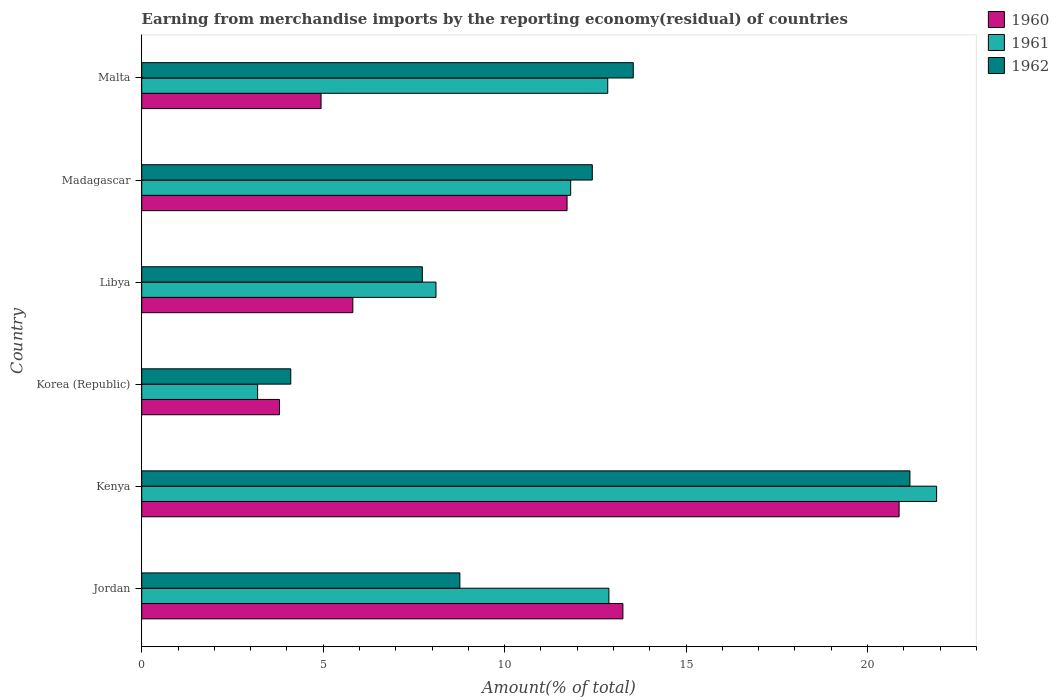How many different coloured bars are there?
Make the answer very short. 3. How many groups of bars are there?
Your response must be concise. 6. How many bars are there on the 3rd tick from the top?
Offer a terse response. 3. How many bars are there on the 3rd tick from the bottom?
Make the answer very short. 3. What is the percentage of amount earned from merchandise imports in 1962 in Jordan?
Provide a short and direct response. 8.77. Across all countries, what is the maximum percentage of amount earned from merchandise imports in 1961?
Provide a succinct answer. 21.91. Across all countries, what is the minimum percentage of amount earned from merchandise imports in 1960?
Your answer should be very brief. 3.8. In which country was the percentage of amount earned from merchandise imports in 1960 maximum?
Make the answer very short. Kenya. What is the total percentage of amount earned from merchandise imports in 1961 in the graph?
Offer a very short reply. 70.75. What is the difference between the percentage of amount earned from merchandise imports in 1960 in Libya and that in Malta?
Provide a short and direct response. 0.88. What is the difference between the percentage of amount earned from merchandise imports in 1961 in Madagascar and the percentage of amount earned from merchandise imports in 1960 in Korea (Republic)?
Your answer should be very brief. 8.03. What is the average percentage of amount earned from merchandise imports in 1962 per country?
Ensure brevity in your answer.  11.29. What is the difference between the percentage of amount earned from merchandise imports in 1962 and percentage of amount earned from merchandise imports in 1961 in Korea (Republic)?
Make the answer very short. 0.91. In how many countries, is the percentage of amount earned from merchandise imports in 1960 greater than 12 %?
Make the answer very short. 2. What is the ratio of the percentage of amount earned from merchandise imports in 1962 in Kenya to that in Korea (Republic)?
Keep it short and to the point. 5.15. Is the percentage of amount earned from merchandise imports in 1961 in Jordan less than that in Libya?
Provide a succinct answer. No. Is the difference between the percentage of amount earned from merchandise imports in 1962 in Jordan and Kenya greater than the difference between the percentage of amount earned from merchandise imports in 1961 in Jordan and Kenya?
Offer a terse response. No. What is the difference between the highest and the second highest percentage of amount earned from merchandise imports in 1962?
Your response must be concise. 7.62. What is the difference between the highest and the lowest percentage of amount earned from merchandise imports in 1960?
Your response must be concise. 17.08. How many bars are there?
Offer a very short reply. 18. What is the difference between two consecutive major ticks on the X-axis?
Give a very brief answer. 5. Does the graph contain grids?
Offer a terse response. No. Where does the legend appear in the graph?
Your response must be concise. Top right. How many legend labels are there?
Your response must be concise. 3. What is the title of the graph?
Your answer should be compact. Earning from merchandise imports by the reporting economy(residual) of countries. What is the label or title of the X-axis?
Offer a very short reply. Amount(% of total). What is the Amount(% of total) in 1960 in Jordan?
Keep it short and to the point. 13.26. What is the Amount(% of total) of 1961 in Jordan?
Keep it short and to the point. 12.88. What is the Amount(% of total) of 1962 in Jordan?
Provide a succinct answer. 8.77. What is the Amount(% of total) of 1960 in Kenya?
Make the answer very short. 20.87. What is the Amount(% of total) of 1961 in Kenya?
Provide a succinct answer. 21.91. What is the Amount(% of total) of 1962 in Kenya?
Keep it short and to the point. 21.17. What is the Amount(% of total) in 1960 in Korea (Republic)?
Provide a succinct answer. 3.8. What is the Amount(% of total) of 1961 in Korea (Republic)?
Give a very brief answer. 3.19. What is the Amount(% of total) in 1962 in Korea (Republic)?
Offer a very short reply. 4.11. What is the Amount(% of total) in 1960 in Libya?
Provide a short and direct response. 5.82. What is the Amount(% of total) in 1961 in Libya?
Keep it short and to the point. 8.11. What is the Amount(% of total) in 1962 in Libya?
Offer a very short reply. 7.73. What is the Amount(% of total) in 1960 in Madagascar?
Your answer should be compact. 11.72. What is the Amount(% of total) in 1961 in Madagascar?
Make the answer very short. 11.82. What is the Amount(% of total) in 1962 in Madagascar?
Give a very brief answer. 12.42. What is the Amount(% of total) of 1960 in Malta?
Make the answer very short. 4.94. What is the Amount(% of total) in 1961 in Malta?
Ensure brevity in your answer.  12.84. What is the Amount(% of total) in 1962 in Malta?
Make the answer very short. 13.55. Across all countries, what is the maximum Amount(% of total) of 1960?
Your answer should be very brief. 20.87. Across all countries, what is the maximum Amount(% of total) in 1961?
Provide a succinct answer. 21.91. Across all countries, what is the maximum Amount(% of total) of 1962?
Offer a terse response. 21.17. Across all countries, what is the minimum Amount(% of total) of 1960?
Offer a very short reply. 3.8. Across all countries, what is the minimum Amount(% of total) in 1961?
Give a very brief answer. 3.19. Across all countries, what is the minimum Amount(% of total) in 1962?
Ensure brevity in your answer.  4.11. What is the total Amount(% of total) of 1960 in the graph?
Offer a terse response. 60.41. What is the total Amount(% of total) of 1961 in the graph?
Your response must be concise. 70.75. What is the total Amount(% of total) in 1962 in the graph?
Your answer should be very brief. 67.74. What is the difference between the Amount(% of total) in 1960 in Jordan and that in Kenya?
Provide a short and direct response. -7.61. What is the difference between the Amount(% of total) in 1961 in Jordan and that in Kenya?
Give a very brief answer. -9.03. What is the difference between the Amount(% of total) in 1962 in Jordan and that in Kenya?
Make the answer very short. -12.4. What is the difference between the Amount(% of total) of 1960 in Jordan and that in Korea (Republic)?
Keep it short and to the point. 9.46. What is the difference between the Amount(% of total) of 1961 in Jordan and that in Korea (Republic)?
Keep it short and to the point. 9.68. What is the difference between the Amount(% of total) in 1962 in Jordan and that in Korea (Republic)?
Keep it short and to the point. 4.66. What is the difference between the Amount(% of total) of 1960 in Jordan and that in Libya?
Offer a terse response. 7.44. What is the difference between the Amount(% of total) in 1961 in Jordan and that in Libya?
Ensure brevity in your answer.  4.77. What is the difference between the Amount(% of total) of 1962 in Jordan and that in Libya?
Offer a terse response. 1.03. What is the difference between the Amount(% of total) of 1960 in Jordan and that in Madagascar?
Your answer should be compact. 1.54. What is the difference between the Amount(% of total) of 1961 in Jordan and that in Madagascar?
Provide a short and direct response. 1.05. What is the difference between the Amount(% of total) of 1962 in Jordan and that in Madagascar?
Your response must be concise. -3.65. What is the difference between the Amount(% of total) of 1960 in Jordan and that in Malta?
Provide a short and direct response. 8.32. What is the difference between the Amount(% of total) of 1961 in Jordan and that in Malta?
Offer a very short reply. 0.03. What is the difference between the Amount(% of total) of 1962 in Jordan and that in Malta?
Keep it short and to the point. -4.78. What is the difference between the Amount(% of total) of 1960 in Kenya and that in Korea (Republic)?
Offer a very short reply. 17.08. What is the difference between the Amount(% of total) of 1961 in Kenya and that in Korea (Republic)?
Keep it short and to the point. 18.71. What is the difference between the Amount(% of total) of 1962 in Kenya and that in Korea (Republic)?
Make the answer very short. 17.06. What is the difference between the Amount(% of total) of 1960 in Kenya and that in Libya?
Make the answer very short. 15.06. What is the difference between the Amount(% of total) of 1961 in Kenya and that in Libya?
Your response must be concise. 13.8. What is the difference between the Amount(% of total) of 1962 in Kenya and that in Libya?
Ensure brevity in your answer.  13.44. What is the difference between the Amount(% of total) in 1960 in Kenya and that in Madagascar?
Ensure brevity in your answer.  9.15. What is the difference between the Amount(% of total) in 1961 in Kenya and that in Madagascar?
Ensure brevity in your answer.  10.09. What is the difference between the Amount(% of total) in 1962 in Kenya and that in Madagascar?
Give a very brief answer. 8.75. What is the difference between the Amount(% of total) in 1960 in Kenya and that in Malta?
Provide a short and direct response. 15.93. What is the difference between the Amount(% of total) of 1961 in Kenya and that in Malta?
Keep it short and to the point. 9.06. What is the difference between the Amount(% of total) of 1962 in Kenya and that in Malta?
Provide a succinct answer. 7.62. What is the difference between the Amount(% of total) in 1960 in Korea (Republic) and that in Libya?
Provide a short and direct response. -2.02. What is the difference between the Amount(% of total) in 1961 in Korea (Republic) and that in Libya?
Your response must be concise. -4.92. What is the difference between the Amount(% of total) in 1962 in Korea (Republic) and that in Libya?
Provide a succinct answer. -3.63. What is the difference between the Amount(% of total) in 1960 in Korea (Republic) and that in Madagascar?
Give a very brief answer. -7.93. What is the difference between the Amount(% of total) of 1961 in Korea (Republic) and that in Madagascar?
Your answer should be compact. -8.63. What is the difference between the Amount(% of total) of 1962 in Korea (Republic) and that in Madagascar?
Give a very brief answer. -8.31. What is the difference between the Amount(% of total) in 1960 in Korea (Republic) and that in Malta?
Offer a very short reply. -1.15. What is the difference between the Amount(% of total) in 1961 in Korea (Republic) and that in Malta?
Keep it short and to the point. -9.65. What is the difference between the Amount(% of total) of 1962 in Korea (Republic) and that in Malta?
Your answer should be very brief. -9.44. What is the difference between the Amount(% of total) of 1960 in Libya and that in Madagascar?
Your answer should be very brief. -5.9. What is the difference between the Amount(% of total) of 1961 in Libya and that in Madagascar?
Ensure brevity in your answer.  -3.71. What is the difference between the Amount(% of total) in 1962 in Libya and that in Madagascar?
Offer a terse response. -4.68. What is the difference between the Amount(% of total) of 1960 in Libya and that in Malta?
Your response must be concise. 0.88. What is the difference between the Amount(% of total) of 1961 in Libya and that in Malta?
Provide a succinct answer. -4.73. What is the difference between the Amount(% of total) of 1962 in Libya and that in Malta?
Offer a very short reply. -5.81. What is the difference between the Amount(% of total) in 1960 in Madagascar and that in Malta?
Give a very brief answer. 6.78. What is the difference between the Amount(% of total) of 1961 in Madagascar and that in Malta?
Provide a succinct answer. -1.02. What is the difference between the Amount(% of total) in 1962 in Madagascar and that in Malta?
Give a very brief answer. -1.13. What is the difference between the Amount(% of total) in 1960 in Jordan and the Amount(% of total) in 1961 in Kenya?
Provide a succinct answer. -8.65. What is the difference between the Amount(% of total) of 1960 in Jordan and the Amount(% of total) of 1962 in Kenya?
Your response must be concise. -7.91. What is the difference between the Amount(% of total) of 1961 in Jordan and the Amount(% of total) of 1962 in Kenya?
Offer a very short reply. -8.3. What is the difference between the Amount(% of total) of 1960 in Jordan and the Amount(% of total) of 1961 in Korea (Republic)?
Your answer should be very brief. 10.07. What is the difference between the Amount(% of total) of 1960 in Jordan and the Amount(% of total) of 1962 in Korea (Republic)?
Provide a succinct answer. 9.15. What is the difference between the Amount(% of total) in 1961 in Jordan and the Amount(% of total) in 1962 in Korea (Republic)?
Ensure brevity in your answer.  8.77. What is the difference between the Amount(% of total) in 1960 in Jordan and the Amount(% of total) in 1961 in Libya?
Your answer should be compact. 5.15. What is the difference between the Amount(% of total) of 1960 in Jordan and the Amount(% of total) of 1962 in Libya?
Your answer should be very brief. 5.53. What is the difference between the Amount(% of total) of 1961 in Jordan and the Amount(% of total) of 1962 in Libya?
Ensure brevity in your answer.  5.14. What is the difference between the Amount(% of total) in 1960 in Jordan and the Amount(% of total) in 1961 in Madagascar?
Make the answer very short. 1.44. What is the difference between the Amount(% of total) of 1960 in Jordan and the Amount(% of total) of 1962 in Madagascar?
Make the answer very short. 0.84. What is the difference between the Amount(% of total) of 1961 in Jordan and the Amount(% of total) of 1962 in Madagascar?
Provide a short and direct response. 0.46. What is the difference between the Amount(% of total) in 1960 in Jordan and the Amount(% of total) in 1961 in Malta?
Your response must be concise. 0.42. What is the difference between the Amount(% of total) of 1960 in Jordan and the Amount(% of total) of 1962 in Malta?
Provide a succinct answer. -0.29. What is the difference between the Amount(% of total) of 1961 in Jordan and the Amount(% of total) of 1962 in Malta?
Give a very brief answer. -0.67. What is the difference between the Amount(% of total) in 1960 in Kenya and the Amount(% of total) in 1961 in Korea (Republic)?
Your answer should be compact. 17.68. What is the difference between the Amount(% of total) of 1960 in Kenya and the Amount(% of total) of 1962 in Korea (Republic)?
Provide a short and direct response. 16.77. What is the difference between the Amount(% of total) of 1961 in Kenya and the Amount(% of total) of 1962 in Korea (Republic)?
Your answer should be very brief. 17.8. What is the difference between the Amount(% of total) of 1960 in Kenya and the Amount(% of total) of 1961 in Libya?
Give a very brief answer. 12.76. What is the difference between the Amount(% of total) in 1960 in Kenya and the Amount(% of total) in 1962 in Libya?
Offer a very short reply. 13.14. What is the difference between the Amount(% of total) of 1961 in Kenya and the Amount(% of total) of 1962 in Libya?
Provide a succinct answer. 14.17. What is the difference between the Amount(% of total) of 1960 in Kenya and the Amount(% of total) of 1961 in Madagascar?
Ensure brevity in your answer.  9.05. What is the difference between the Amount(% of total) in 1960 in Kenya and the Amount(% of total) in 1962 in Madagascar?
Offer a very short reply. 8.46. What is the difference between the Amount(% of total) of 1961 in Kenya and the Amount(% of total) of 1962 in Madagascar?
Your response must be concise. 9.49. What is the difference between the Amount(% of total) of 1960 in Kenya and the Amount(% of total) of 1961 in Malta?
Provide a short and direct response. 8.03. What is the difference between the Amount(% of total) in 1960 in Kenya and the Amount(% of total) in 1962 in Malta?
Your answer should be very brief. 7.33. What is the difference between the Amount(% of total) of 1961 in Kenya and the Amount(% of total) of 1962 in Malta?
Ensure brevity in your answer.  8.36. What is the difference between the Amount(% of total) of 1960 in Korea (Republic) and the Amount(% of total) of 1961 in Libya?
Your response must be concise. -4.31. What is the difference between the Amount(% of total) of 1960 in Korea (Republic) and the Amount(% of total) of 1962 in Libya?
Offer a very short reply. -3.94. What is the difference between the Amount(% of total) of 1961 in Korea (Republic) and the Amount(% of total) of 1962 in Libya?
Offer a very short reply. -4.54. What is the difference between the Amount(% of total) of 1960 in Korea (Republic) and the Amount(% of total) of 1961 in Madagascar?
Offer a terse response. -8.03. What is the difference between the Amount(% of total) of 1960 in Korea (Republic) and the Amount(% of total) of 1962 in Madagascar?
Ensure brevity in your answer.  -8.62. What is the difference between the Amount(% of total) of 1961 in Korea (Republic) and the Amount(% of total) of 1962 in Madagascar?
Provide a succinct answer. -9.22. What is the difference between the Amount(% of total) of 1960 in Korea (Republic) and the Amount(% of total) of 1961 in Malta?
Offer a very short reply. -9.05. What is the difference between the Amount(% of total) in 1960 in Korea (Republic) and the Amount(% of total) in 1962 in Malta?
Your answer should be compact. -9.75. What is the difference between the Amount(% of total) of 1961 in Korea (Republic) and the Amount(% of total) of 1962 in Malta?
Ensure brevity in your answer.  -10.35. What is the difference between the Amount(% of total) of 1960 in Libya and the Amount(% of total) of 1961 in Madagascar?
Offer a terse response. -6. What is the difference between the Amount(% of total) of 1960 in Libya and the Amount(% of total) of 1962 in Madagascar?
Your answer should be very brief. -6.6. What is the difference between the Amount(% of total) of 1961 in Libya and the Amount(% of total) of 1962 in Madagascar?
Make the answer very short. -4.31. What is the difference between the Amount(% of total) in 1960 in Libya and the Amount(% of total) in 1961 in Malta?
Provide a short and direct response. -7.03. What is the difference between the Amount(% of total) of 1960 in Libya and the Amount(% of total) of 1962 in Malta?
Your answer should be very brief. -7.73. What is the difference between the Amount(% of total) of 1961 in Libya and the Amount(% of total) of 1962 in Malta?
Ensure brevity in your answer.  -5.44. What is the difference between the Amount(% of total) in 1960 in Madagascar and the Amount(% of total) in 1961 in Malta?
Offer a very short reply. -1.12. What is the difference between the Amount(% of total) in 1960 in Madagascar and the Amount(% of total) in 1962 in Malta?
Your answer should be very brief. -1.82. What is the difference between the Amount(% of total) in 1961 in Madagascar and the Amount(% of total) in 1962 in Malta?
Provide a succinct answer. -1.73. What is the average Amount(% of total) of 1960 per country?
Ensure brevity in your answer.  10.07. What is the average Amount(% of total) in 1961 per country?
Keep it short and to the point. 11.79. What is the average Amount(% of total) in 1962 per country?
Provide a short and direct response. 11.29. What is the difference between the Amount(% of total) in 1960 and Amount(% of total) in 1961 in Jordan?
Keep it short and to the point. 0.39. What is the difference between the Amount(% of total) in 1960 and Amount(% of total) in 1962 in Jordan?
Make the answer very short. 4.49. What is the difference between the Amount(% of total) in 1961 and Amount(% of total) in 1962 in Jordan?
Ensure brevity in your answer.  4.11. What is the difference between the Amount(% of total) of 1960 and Amount(% of total) of 1961 in Kenya?
Your response must be concise. -1.03. What is the difference between the Amount(% of total) of 1960 and Amount(% of total) of 1962 in Kenya?
Provide a short and direct response. -0.3. What is the difference between the Amount(% of total) in 1961 and Amount(% of total) in 1962 in Kenya?
Keep it short and to the point. 0.74. What is the difference between the Amount(% of total) of 1960 and Amount(% of total) of 1961 in Korea (Republic)?
Offer a very short reply. 0.6. What is the difference between the Amount(% of total) in 1960 and Amount(% of total) in 1962 in Korea (Republic)?
Your answer should be very brief. -0.31. What is the difference between the Amount(% of total) in 1961 and Amount(% of total) in 1962 in Korea (Republic)?
Offer a very short reply. -0.91. What is the difference between the Amount(% of total) in 1960 and Amount(% of total) in 1961 in Libya?
Your answer should be compact. -2.29. What is the difference between the Amount(% of total) of 1960 and Amount(% of total) of 1962 in Libya?
Provide a succinct answer. -1.92. What is the difference between the Amount(% of total) of 1961 and Amount(% of total) of 1962 in Libya?
Give a very brief answer. 0.38. What is the difference between the Amount(% of total) of 1960 and Amount(% of total) of 1961 in Madagascar?
Offer a very short reply. -0.1. What is the difference between the Amount(% of total) in 1960 and Amount(% of total) in 1962 in Madagascar?
Ensure brevity in your answer.  -0.7. What is the difference between the Amount(% of total) in 1961 and Amount(% of total) in 1962 in Madagascar?
Provide a succinct answer. -0.6. What is the difference between the Amount(% of total) in 1960 and Amount(% of total) in 1961 in Malta?
Give a very brief answer. -7.9. What is the difference between the Amount(% of total) in 1960 and Amount(% of total) in 1962 in Malta?
Offer a terse response. -8.6. What is the difference between the Amount(% of total) in 1961 and Amount(% of total) in 1962 in Malta?
Give a very brief answer. -0.7. What is the ratio of the Amount(% of total) of 1960 in Jordan to that in Kenya?
Offer a very short reply. 0.64. What is the ratio of the Amount(% of total) in 1961 in Jordan to that in Kenya?
Keep it short and to the point. 0.59. What is the ratio of the Amount(% of total) in 1962 in Jordan to that in Kenya?
Your answer should be compact. 0.41. What is the ratio of the Amount(% of total) in 1960 in Jordan to that in Korea (Republic)?
Provide a succinct answer. 3.49. What is the ratio of the Amount(% of total) of 1961 in Jordan to that in Korea (Republic)?
Offer a very short reply. 4.03. What is the ratio of the Amount(% of total) of 1962 in Jordan to that in Korea (Republic)?
Provide a short and direct response. 2.13. What is the ratio of the Amount(% of total) in 1960 in Jordan to that in Libya?
Provide a succinct answer. 2.28. What is the ratio of the Amount(% of total) of 1961 in Jordan to that in Libya?
Your response must be concise. 1.59. What is the ratio of the Amount(% of total) of 1962 in Jordan to that in Libya?
Ensure brevity in your answer.  1.13. What is the ratio of the Amount(% of total) in 1960 in Jordan to that in Madagascar?
Ensure brevity in your answer.  1.13. What is the ratio of the Amount(% of total) in 1961 in Jordan to that in Madagascar?
Give a very brief answer. 1.09. What is the ratio of the Amount(% of total) of 1962 in Jordan to that in Madagascar?
Offer a very short reply. 0.71. What is the ratio of the Amount(% of total) in 1960 in Jordan to that in Malta?
Your answer should be compact. 2.68. What is the ratio of the Amount(% of total) in 1961 in Jordan to that in Malta?
Give a very brief answer. 1. What is the ratio of the Amount(% of total) of 1962 in Jordan to that in Malta?
Your response must be concise. 0.65. What is the ratio of the Amount(% of total) in 1960 in Kenya to that in Korea (Republic)?
Your answer should be compact. 5.5. What is the ratio of the Amount(% of total) in 1961 in Kenya to that in Korea (Republic)?
Provide a succinct answer. 6.86. What is the ratio of the Amount(% of total) in 1962 in Kenya to that in Korea (Republic)?
Provide a short and direct response. 5.15. What is the ratio of the Amount(% of total) in 1960 in Kenya to that in Libya?
Offer a very short reply. 3.59. What is the ratio of the Amount(% of total) of 1961 in Kenya to that in Libya?
Offer a very short reply. 2.7. What is the ratio of the Amount(% of total) of 1962 in Kenya to that in Libya?
Provide a succinct answer. 2.74. What is the ratio of the Amount(% of total) in 1960 in Kenya to that in Madagascar?
Your answer should be very brief. 1.78. What is the ratio of the Amount(% of total) of 1961 in Kenya to that in Madagascar?
Offer a terse response. 1.85. What is the ratio of the Amount(% of total) in 1962 in Kenya to that in Madagascar?
Your answer should be very brief. 1.7. What is the ratio of the Amount(% of total) in 1960 in Kenya to that in Malta?
Keep it short and to the point. 4.22. What is the ratio of the Amount(% of total) in 1961 in Kenya to that in Malta?
Make the answer very short. 1.71. What is the ratio of the Amount(% of total) in 1962 in Kenya to that in Malta?
Your answer should be very brief. 1.56. What is the ratio of the Amount(% of total) of 1960 in Korea (Republic) to that in Libya?
Offer a terse response. 0.65. What is the ratio of the Amount(% of total) in 1961 in Korea (Republic) to that in Libya?
Your answer should be compact. 0.39. What is the ratio of the Amount(% of total) in 1962 in Korea (Republic) to that in Libya?
Your answer should be very brief. 0.53. What is the ratio of the Amount(% of total) of 1960 in Korea (Republic) to that in Madagascar?
Offer a very short reply. 0.32. What is the ratio of the Amount(% of total) of 1961 in Korea (Republic) to that in Madagascar?
Offer a terse response. 0.27. What is the ratio of the Amount(% of total) in 1962 in Korea (Republic) to that in Madagascar?
Your answer should be very brief. 0.33. What is the ratio of the Amount(% of total) of 1960 in Korea (Republic) to that in Malta?
Your answer should be very brief. 0.77. What is the ratio of the Amount(% of total) in 1961 in Korea (Republic) to that in Malta?
Your answer should be compact. 0.25. What is the ratio of the Amount(% of total) in 1962 in Korea (Republic) to that in Malta?
Offer a very short reply. 0.3. What is the ratio of the Amount(% of total) in 1960 in Libya to that in Madagascar?
Offer a very short reply. 0.5. What is the ratio of the Amount(% of total) of 1961 in Libya to that in Madagascar?
Offer a terse response. 0.69. What is the ratio of the Amount(% of total) in 1962 in Libya to that in Madagascar?
Provide a short and direct response. 0.62. What is the ratio of the Amount(% of total) of 1960 in Libya to that in Malta?
Give a very brief answer. 1.18. What is the ratio of the Amount(% of total) in 1961 in Libya to that in Malta?
Keep it short and to the point. 0.63. What is the ratio of the Amount(% of total) in 1962 in Libya to that in Malta?
Offer a terse response. 0.57. What is the ratio of the Amount(% of total) in 1960 in Madagascar to that in Malta?
Offer a terse response. 2.37. What is the ratio of the Amount(% of total) in 1961 in Madagascar to that in Malta?
Keep it short and to the point. 0.92. What is the ratio of the Amount(% of total) in 1962 in Madagascar to that in Malta?
Keep it short and to the point. 0.92. What is the difference between the highest and the second highest Amount(% of total) of 1960?
Your response must be concise. 7.61. What is the difference between the highest and the second highest Amount(% of total) of 1961?
Provide a short and direct response. 9.03. What is the difference between the highest and the second highest Amount(% of total) in 1962?
Ensure brevity in your answer.  7.62. What is the difference between the highest and the lowest Amount(% of total) in 1960?
Give a very brief answer. 17.08. What is the difference between the highest and the lowest Amount(% of total) of 1961?
Keep it short and to the point. 18.71. What is the difference between the highest and the lowest Amount(% of total) in 1962?
Offer a very short reply. 17.06. 